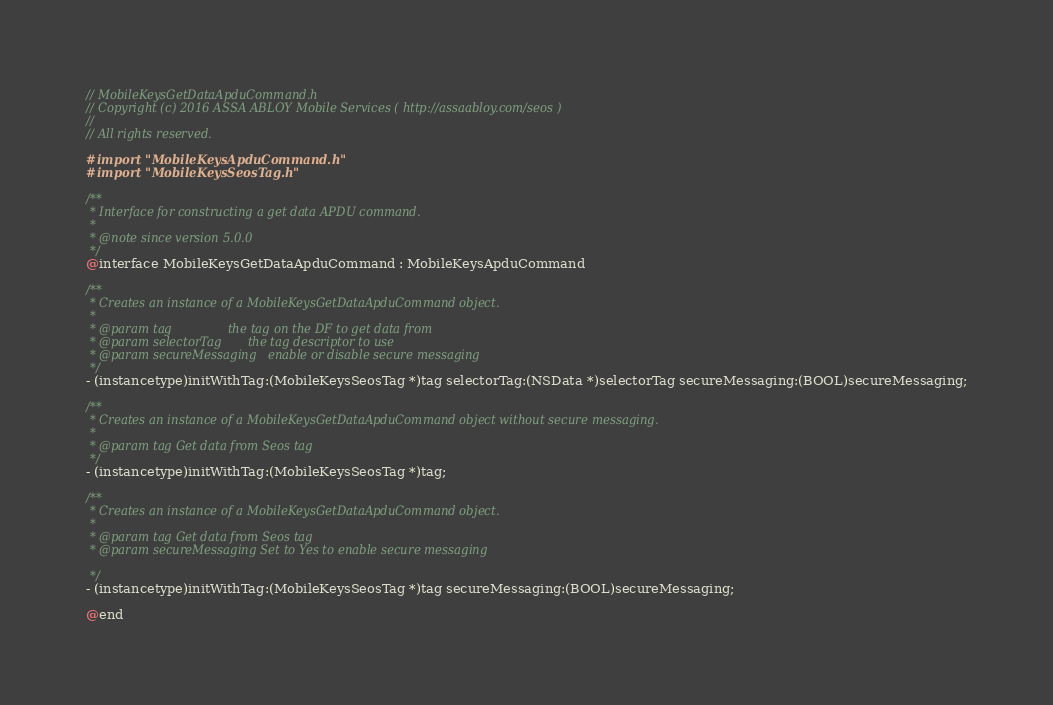<code> <loc_0><loc_0><loc_500><loc_500><_C_>// MobileKeysGetDataApduCommand.h
// Copyright (c) 2016 ASSA ABLOY Mobile Services ( http://assaabloy.com/seos )
//
// All rights reserved.

#import "MobileKeysApduCommand.h"
#import "MobileKeysSeosTag.h"

/**
 * Interface for constructing a get data APDU command.
 *
 * @note since version 5.0.0
 */
@interface MobileKeysGetDataApduCommand : MobileKeysApduCommand

/**
 * Creates an instance of a MobileKeysGetDataApduCommand object.
 *
 * @param tag               the tag on the DF to get data from
 * @param selectorTag       the tag descriptor to use
 * @param secureMessaging   enable or disable secure messaging
 */
- (instancetype)initWithTag:(MobileKeysSeosTag *)tag selectorTag:(NSData *)selectorTag secureMessaging:(BOOL)secureMessaging;

/**
 * Creates an instance of a MobileKeysGetDataApduCommand object without secure messaging.
 *
 * @param tag Get data from Seos tag
 */
- (instancetype)initWithTag:(MobileKeysSeosTag *)tag;

/**
 * Creates an instance of a MobileKeysGetDataApduCommand object.
 *
 * @param tag Get data from Seos tag
 * @param secureMessaging Set to Yes to enable secure messaging

 */
- (instancetype)initWithTag:(MobileKeysSeosTag *)tag secureMessaging:(BOOL)secureMessaging;

@end
</code> 